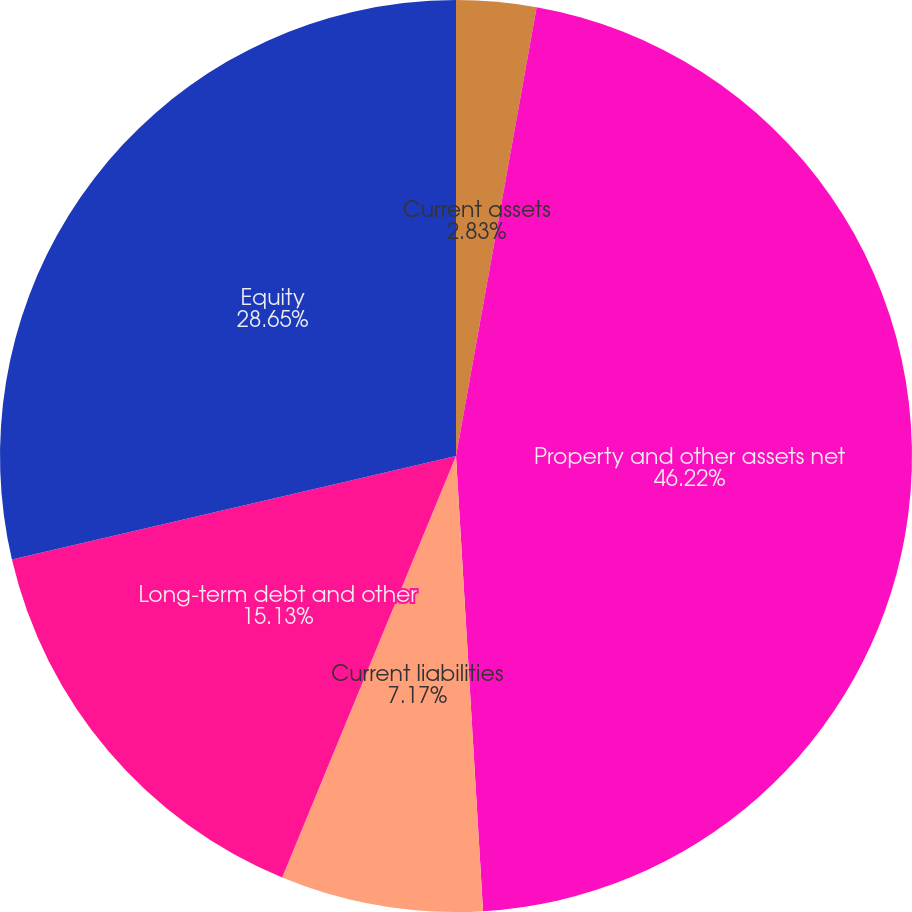Convert chart to OTSL. <chart><loc_0><loc_0><loc_500><loc_500><pie_chart><fcel>Current assets<fcel>Property and other assets net<fcel>Current liabilities<fcel>Long-term debt and other<fcel>Equity<nl><fcel>2.83%<fcel>46.23%<fcel>7.17%<fcel>15.13%<fcel>28.65%<nl></chart> 